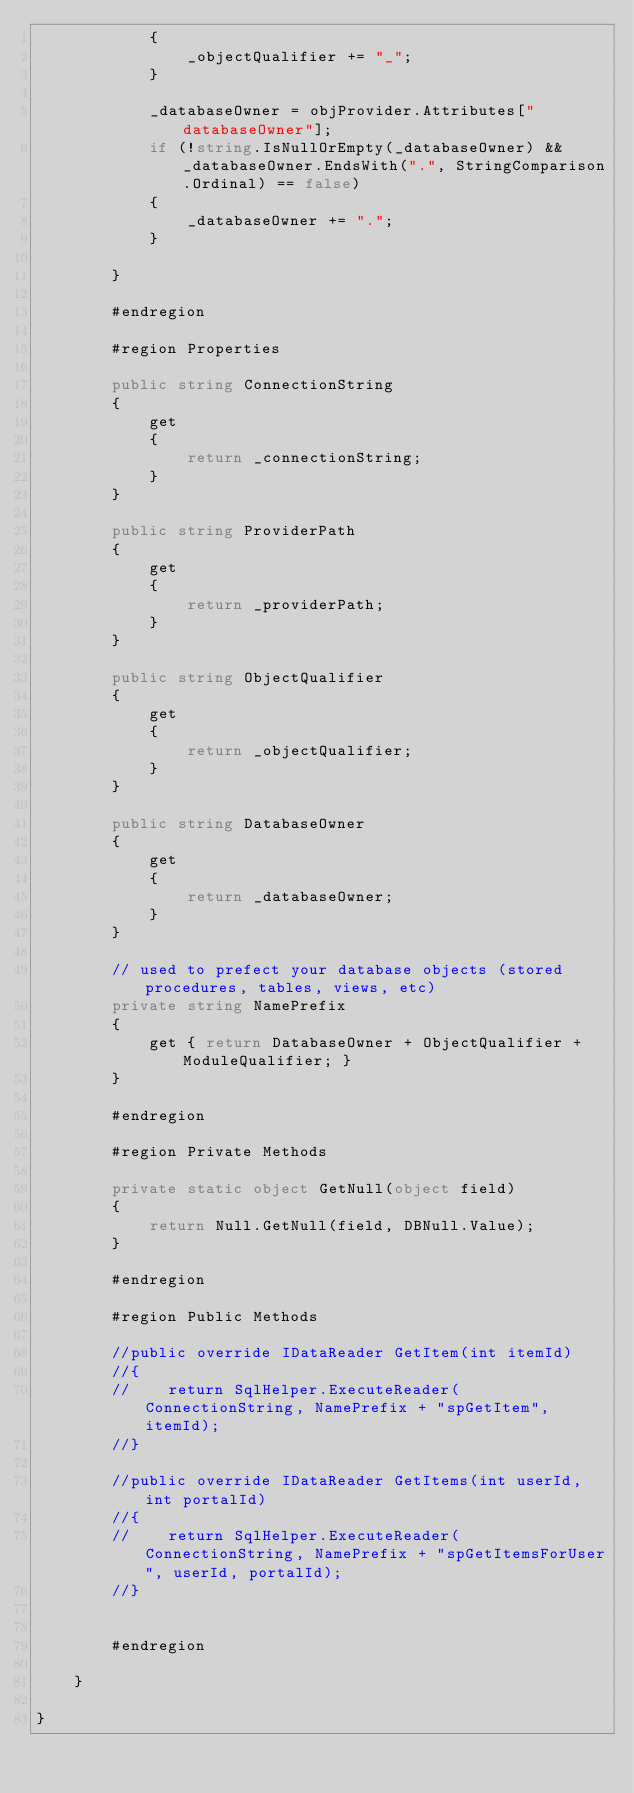<code> <loc_0><loc_0><loc_500><loc_500><_C#_>            {
                _objectQualifier += "_";
            }

            _databaseOwner = objProvider.Attributes["databaseOwner"];
            if (!string.IsNullOrEmpty(_databaseOwner) && _databaseOwner.EndsWith(".", StringComparison.Ordinal) == false)
            {
                _databaseOwner += ".";
            }

        }

        #endregion

        #region Properties

        public string ConnectionString
        {
            get
            {
                return _connectionString;
            }
        }

        public string ProviderPath
        {
            get
            {
                return _providerPath;
            }
        }

        public string ObjectQualifier
        {
            get
            {
                return _objectQualifier;
            }
        }

        public string DatabaseOwner
        {
            get
            {
                return _databaseOwner;
            }
        }

        // used to prefect your database objects (stored procedures, tables, views, etc)
        private string NamePrefix
        {
            get { return DatabaseOwner + ObjectQualifier + ModuleQualifier; }
        }

        #endregion

        #region Private Methods

        private static object GetNull(object field)
        {
            return Null.GetNull(field, DBNull.Value);
        }

        #endregion

        #region Public Methods

        //public override IDataReader GetItem(int itemId)
        //{
        //    return SqlHelper.ExecuteReader(ConnectionString, NamePrefix + "spGetItem", itemId);
        //}

        //public override IDataReader GetItems(int userId, int portalId)
        //{
        //    return SqlHelper.ExecuteReader(ConnectionString, NamePrefix + "spGetItemsForUser", userId, portalId);
        //}


        #endregion

    }

}</code> 